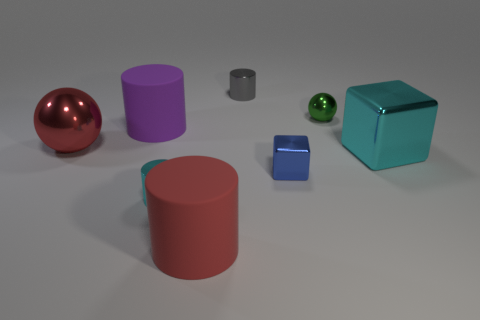Add 1 red balls. How many objects exist? 9 Subtract all cyan cylinders. How many cylinders are left? 3 Subtract all red balls. How many balls are left? 1 Subtract all blocks. How many objects are left? 6 Subtract 1 cubes. How many cubes are left? 1 Subtract all green spheres. Subtract all yellow cylinders. How many spheres are left? 1 Subtract all yellow cubes. How many green balls are left? 1 Subtract all big brown metallic cylinders. Subtract all red shiny balls. How many objects are left? 7 Add 8 tiny green things. How many tiny green things are left? 9 Add 2 cyan objects. How many cyan objects exist? 4 